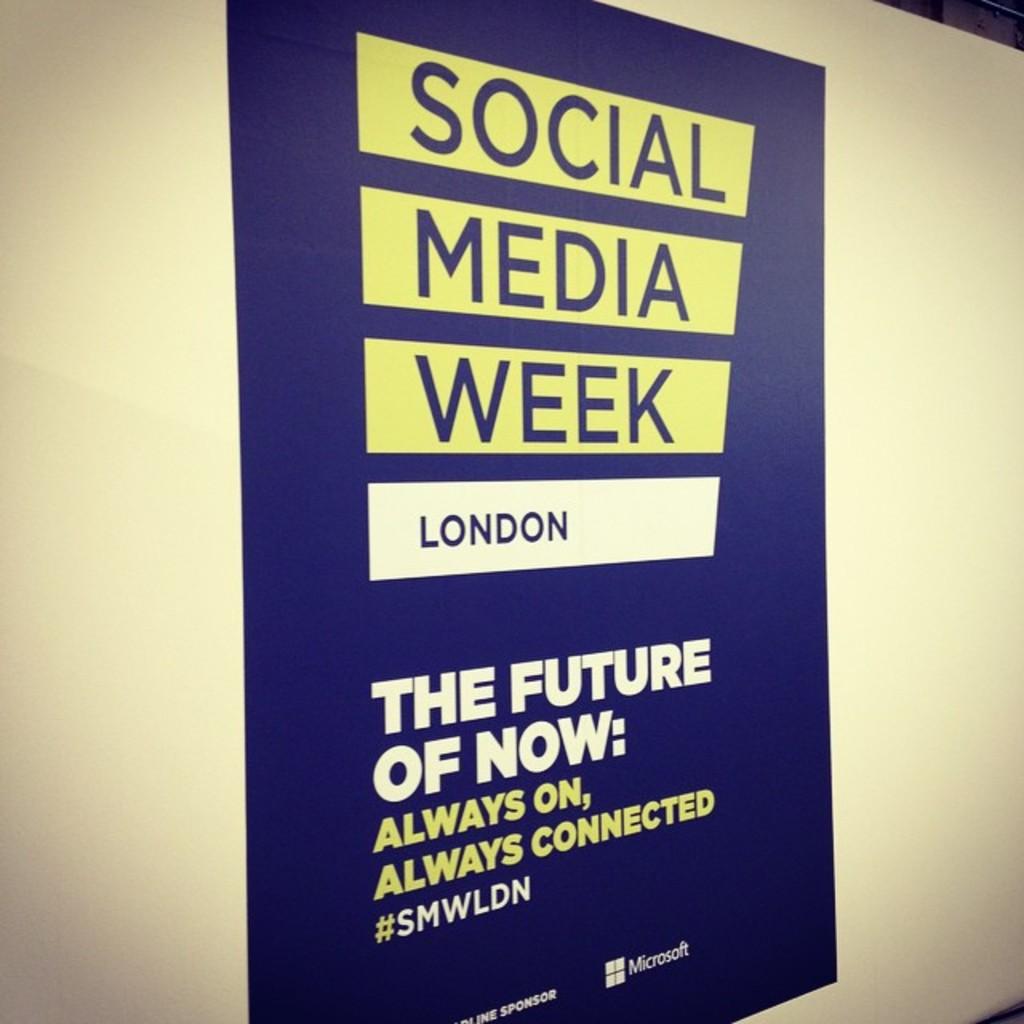Where is social media week taking place?
Provide a succinct answer. London. What is the hashtag for the social media week?
Offer a terse response. Smwldn. 